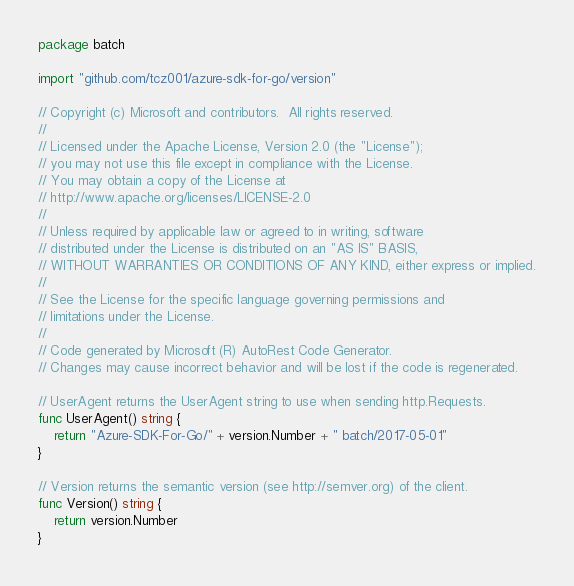<code> <loc_0><loc_0><loc_500><loc_500><_Go_>package batch

import "github.com/tcz001/azure-sdk-for-go/version"

// Copyright (c) Microsoft and contributors.  All rights reserved.
//
// Licensed under the Apache License, Version 2.0 (the "License");
// you may not use this file except in compliance with the License.
// You may obtain a copy of the License at
// http://www.apache.org/licenses/LICENSE-2.0
//
// Unless required by applicable law or agreed to in writing, software
// distributed under the License is distributed on an "AS IS" BASIS,
// WITHOUT WARRANTIES OR CONDITIONS OF ANY KIND, either express or implied.
//
// See the License for the specific language governing permissions and
// limitations under the License.
//
// Code generated by Microsoft (R) AutoRest Code Generator.
// Changes may cause incorrect behavior and will be lost if the code is regenerated.

// UserAgent returns the UserAgent string to use when sending http.Requests.
func UserAgent() string {
	return "Azure-SDK-For-Go/" + version.Number + " batch/2017-05-01"
}

// Version returns the semantic version (see http://semver.org) of the client.
func Version() string {
	return version.Number
}
</code> 